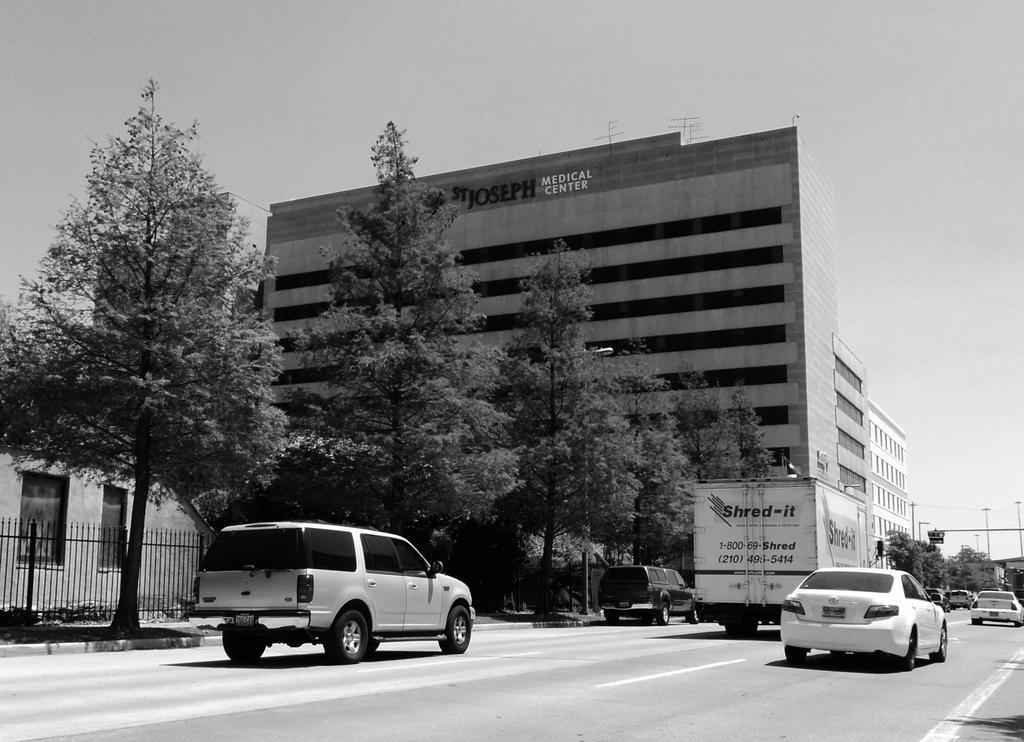Could you give a brief overview of what you see in this image? In the foreground of this image, there are vehicles moving on the road. In the background, there are trees, railing, few buildings, poles and at the top, there is the sky. 